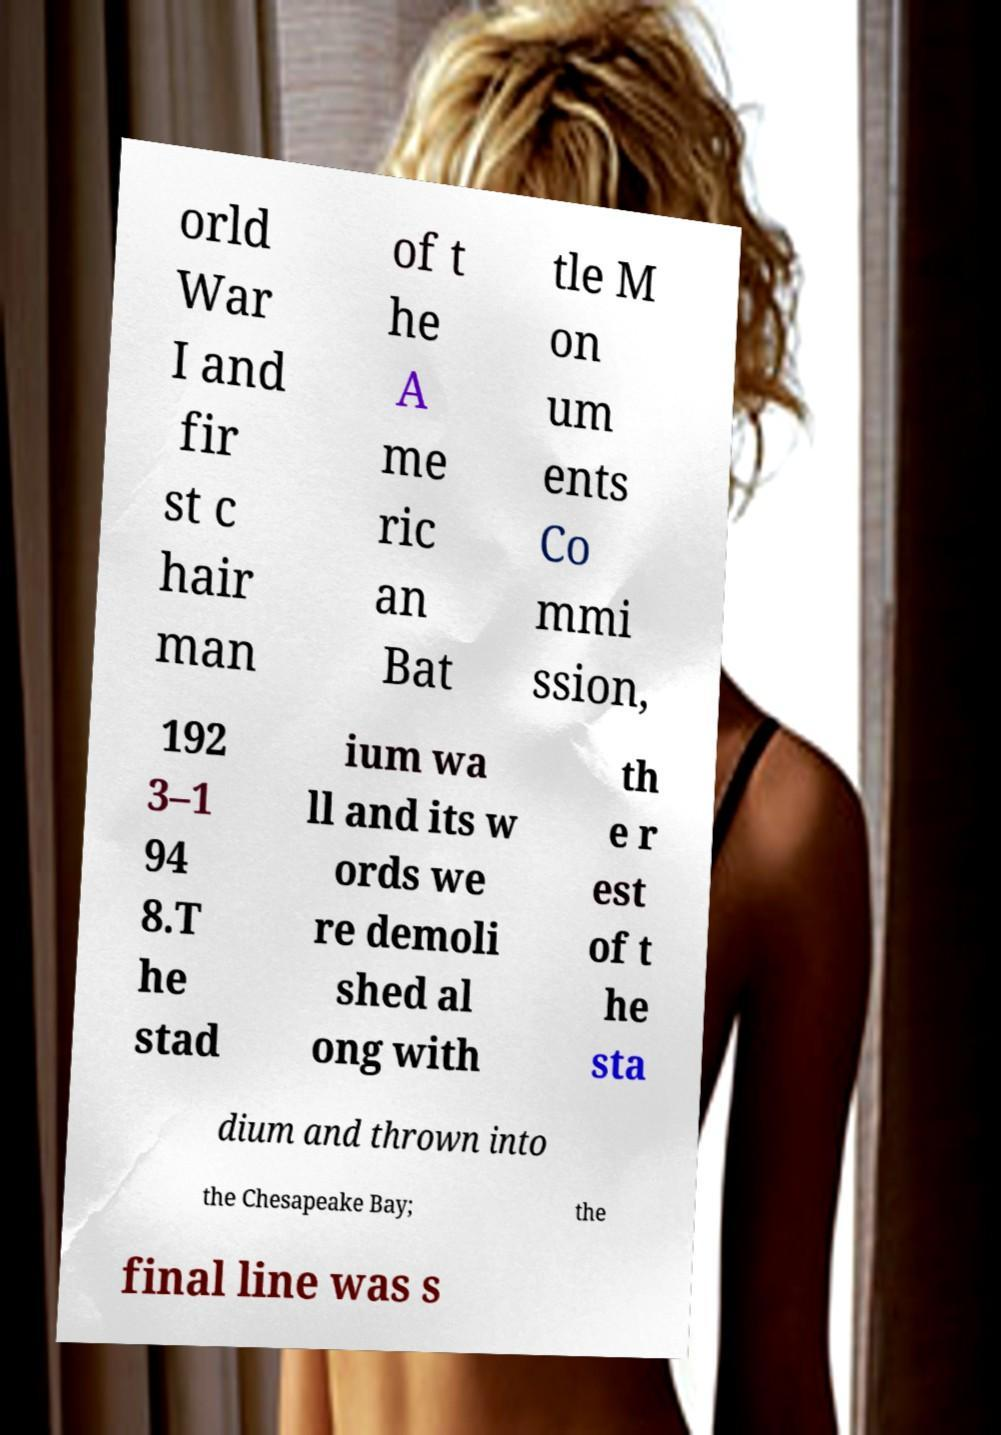Please read and relay the text visible in this image. What does it say? orld War I and fir st c hair man of t he A me ric an Bat tle M on um ents Co mmi ssion, 192 3–1 94 8.T he stad ium wa ll and its w ords we re demoli shed al ong with th e r est of t he sta dium and thrown into the Chesapeake Bay; the final line was s 